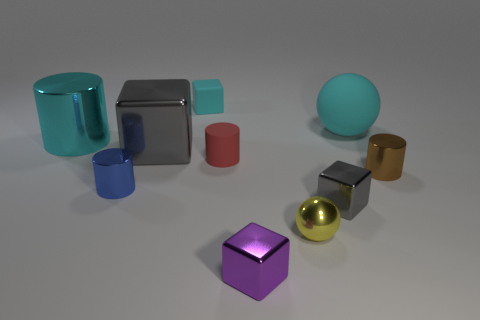The large block has what color?
Ensure brevity in your answer.  Gray. Is the color of the tiny cylinder to the right of the tiny gray metallic object the same as the tiny matte cylinder?
Keep it short and to the point. No. What material is the other cube that is the same color as the large metal block?
Provide a short and direct response. Metal. What number of small metallic cylinders have the same color as the large cylinder?
Offer a very short reply. 0. There is a big cyan thing behind the cyan shiny cylinder; is it the same shape as the small brown shiny thing?
Offer a terse response. No. Are there fewer yellow objects to the left of the rubber sphere than tiny blue shiny objects that are behind the large metallic cube?
Offer a very short reply. No. There is a block in front of the small gray object; what is it made of?
Your answer should be compact. Metal. What is the size of the matte object that is the same color as the matte block?
Make the answer very short. Large. Are there any purple things of the same size as the red cylinder?
Offer a very short reply. Yes. There is a large cyan shiny object; is its shape the same as the tiny metallic thing on the right side of the tiny gray object?
Offer a very short reply. Yes. 